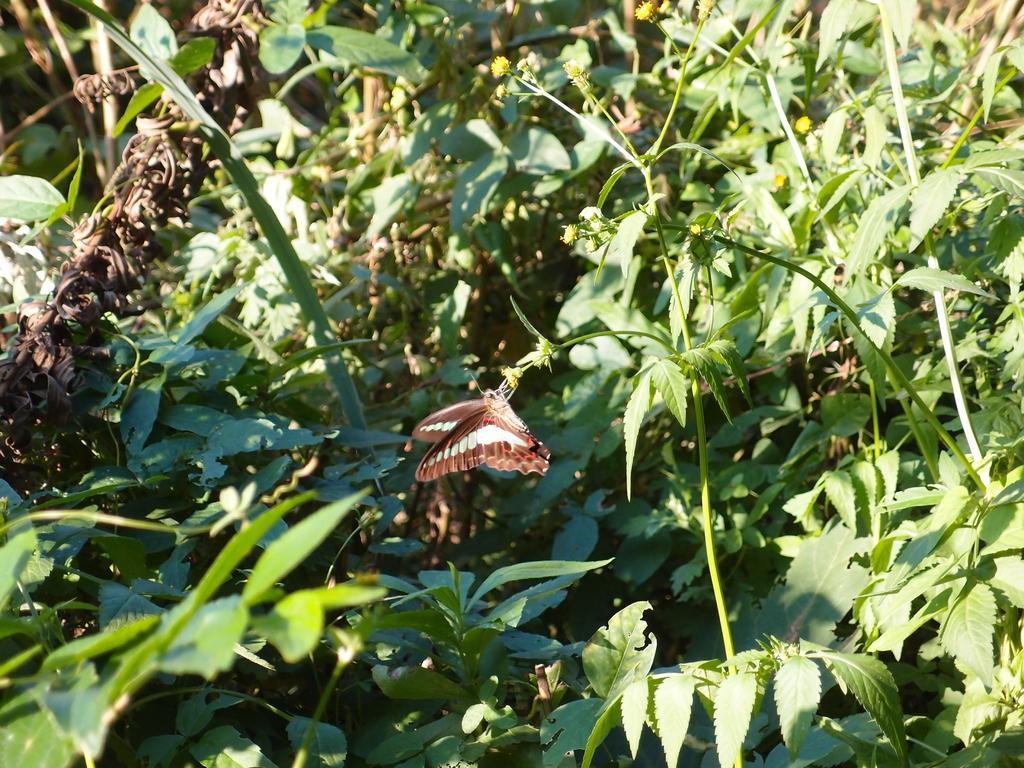Please provide a concise description of this image. In this image we can see some plants with flowers and there is a butterfly on the flower. 